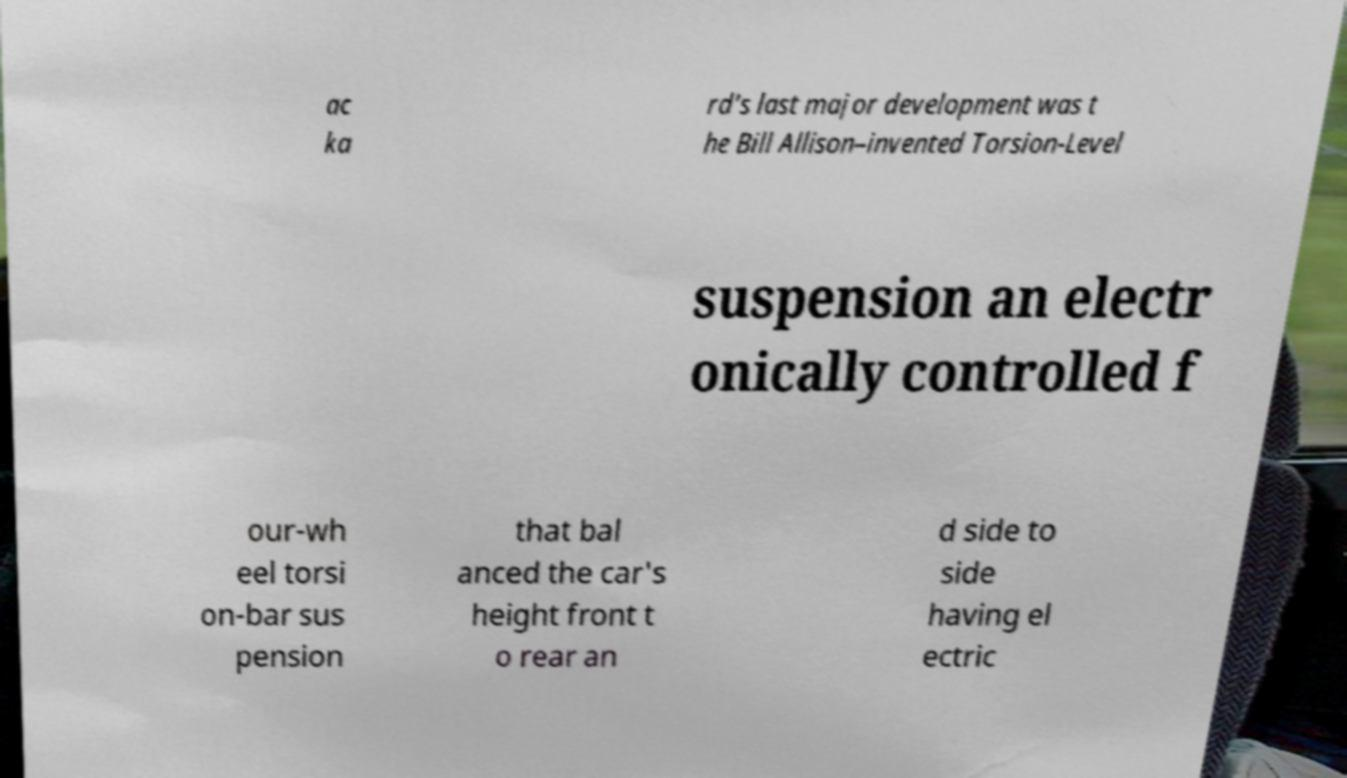For documentation purposes, I need the text within this image transcribed. Could you provide that? ac ka rd's last major development was t he Bill Allison–invented Torsion-Level suspension an electr onically controlled f our-wh eel torsi on-bar sus pension that bal anced the car's height front t o rear an d side to side having el ectric 